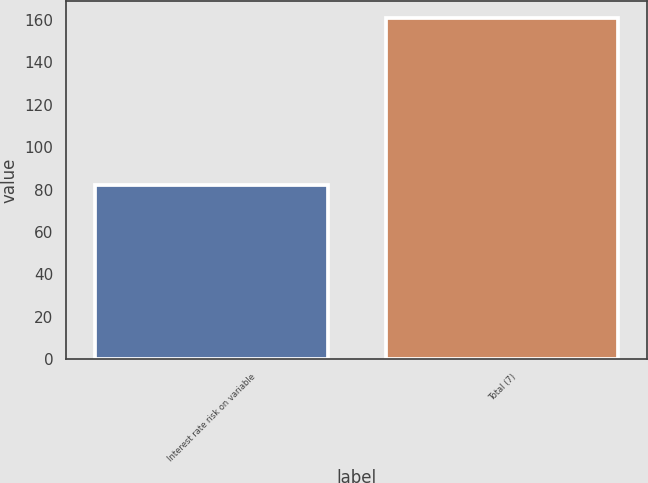Convert chart. <chart><loc_0><loc_0><loc_500><loc_500><bar_chart><fcel>Interest rate risk on variable<fcel>Total (7)<nl><fcel>82<fcel>161<nl></chart> 